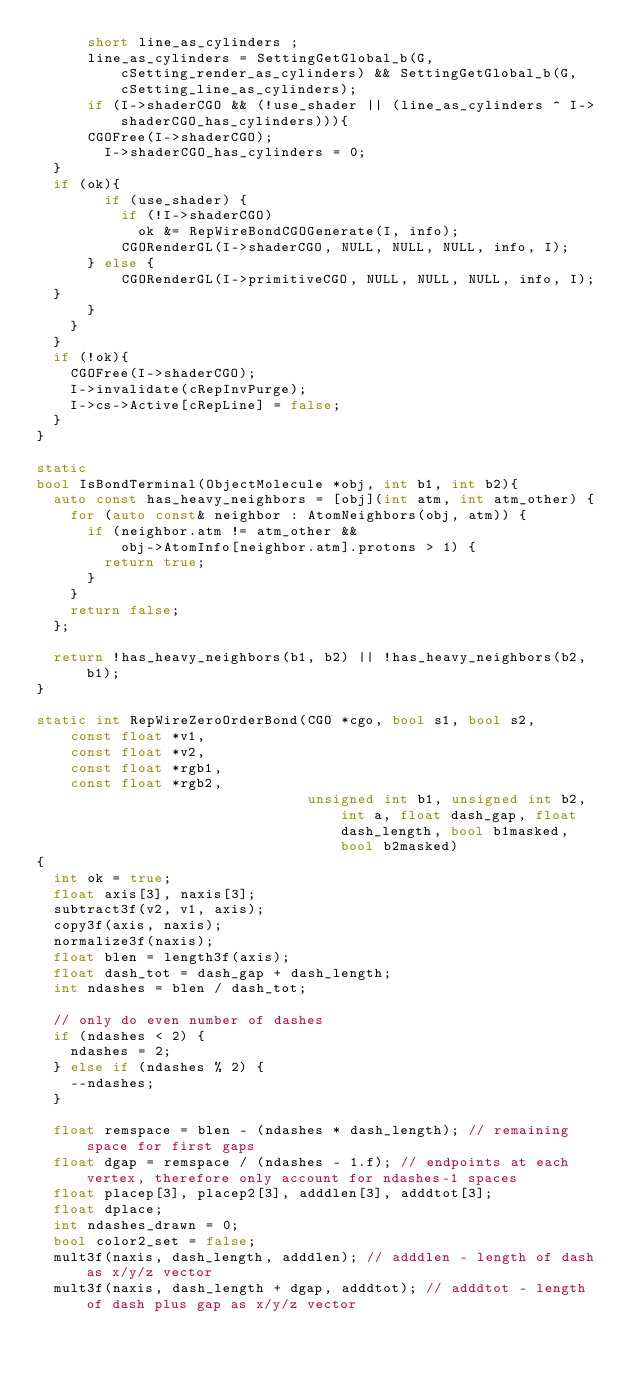Convert code to text. <code><loc_0><loc_0><loc_500><loc_500><_C++_>      short line_as_cylinders ;
      line_as_cylinders = SettingGetGlobal_b(G, cSetting_render_as_cylinders) && SettingGetGlobal_b(G, cSetting_line_as_cylinders);
      if (I->shaderCGO && (!use_shader || (line_as_cylinders ^ I->shaderCGO_has_cylinders))){
      CGOFree(I->shaderCGO);
        I->shaderCGO_has_cylinders = 0;
	}
	if (ok){
        if (use_shader) {
          if (!I->shaderCGO)
            ok &= RepWireBondCGOGenerate(I, info);
          CGORenderGL(I->shaderCGO, NULL, NULL, NULL, info, I);
	    } else {
          CGORenderGL(I->primitiveCGO, NULL, NULL, NULL, info, I);
	}
      }
    }
  }
  if (!ok){
    CGOFree(I->shaderCGO);
    I->invalidate(cRepInvPurge);
    I->cs->Active[cRepLine] = false;
  }
}

static
bool IsBondTerminal(ObjectMolecule *obj, int b1, int b2){
  auto const has_heavy_neighbors = [obj](int atm, int atm_other) {
    for (auto const& neighbor : AtomNeighbors(obj, atm)) {
      if (neighbor.atm != atm_other &&
          obj->AtomInfo[neighbor.atm].protons > 1) {
        return true;
      }
    }
    return false;
  };

  return !has_heavy_neighbors(b1, b2) || !has_heavy_neighbors(b2, b1);
}

static int RepWireZeroOrderBond(CGO *cgo, bool s1, bool s2,
    const float *v1,
    const float *v2,
    const float *rgb1,
    const float *rgb2,
                                unsigned int b1, unsigned int b2, int a, float dash_gap, float dash_length, bool b1masked, bool b2masked)
{
  int ok = true;
  float axis[3], naxis[3];
  subtract3f(v2, v1, axis);
  copy3f(axis, naxis);
  normalize3f(naxis);
  float blen = length3f(axis);
  float dash_tot = dash_gap + dash_length;
  int ndashes = blen / dash_tot;

  // only do even number of dashes
  if (ndashes < 2) {
    ndashes = 2;
  } else if (ndashes % 2) {
    --ndashes;
  }

  float remspace = blen - (ndashes * dash_length); // remaining space for first gaps
  float dgap = remspace / (ndashes - 1.f); // endpoints at each vertex, therefore only account for ndashes-1 spaces
  float placep[3], placep2[3], adddlen[3], adddtot[3];
  float dplace;
  int ndashes_drawn = 0;
  bool color2_set = false;
  mult3f(naxis, dash_length, adddlen); // adddlen - length of dash as x/y/z vector
  mult3f(naxis, dash_length + dgap, adddtot); // adddtot - length of dash plus gap as x/y/z vector
</code> 